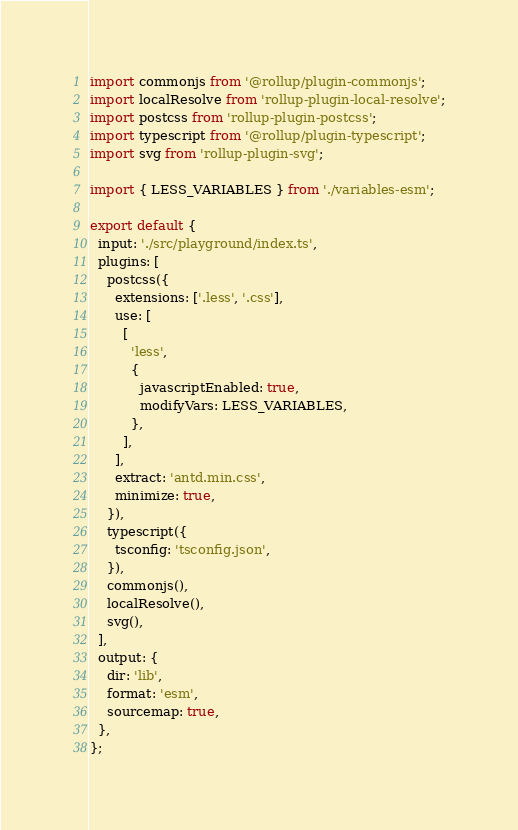Convert code to text. <code><loc_0><loc_0><loc_500><loc_500><_JavaScript_>import commonjs from '@rollup/plugin-commonjs';
import localResolve from 'rollup-plugin-local-resolve';
import postcss from 'rollup-plugin-postcss';
import typescript from '@rollup/plugin-typescript';
import svg from 'rollup-plugin-svg';

import { LESS_VARIABLES } from './variables-esm';

export default {
  input: './src/playground/index.ts',
  plugins: [
    postcss({
      extensions: ['.less', '.css'],
      use: [
        [
          'less',
          {
            javascriptEnabled: true,
            modifyVars: LESS_VARIABLES,
          },
        ],
      ],
      extract: 'antd.min.css',
      minimize: true,
    }),
    typescript({
      tsconfig: 'tsconfig.json',
    }),
    commonjs(),
    localResolve(),
    svg(),
  ],
  output: {
    dir: 'lib',
    format: 'esm',
    sourcemap: true,
  },
};
</code> 